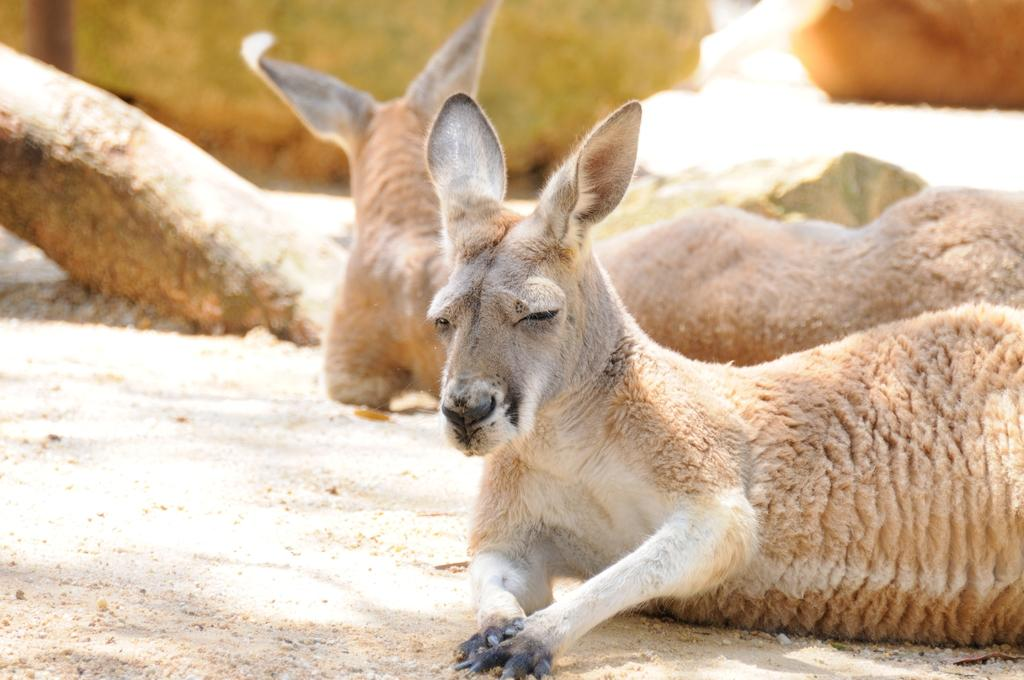What animals are present in the image? There are deer in the picture. What type of ground are the deer sitting on? The deer are sitting on a sand ground. Can you describe the background of the image? There are other objects visible in the background of the image. Who is the owner of the deer in the image? There is no indication of ownership in the image, so it cannot be determined who the owner might be. 